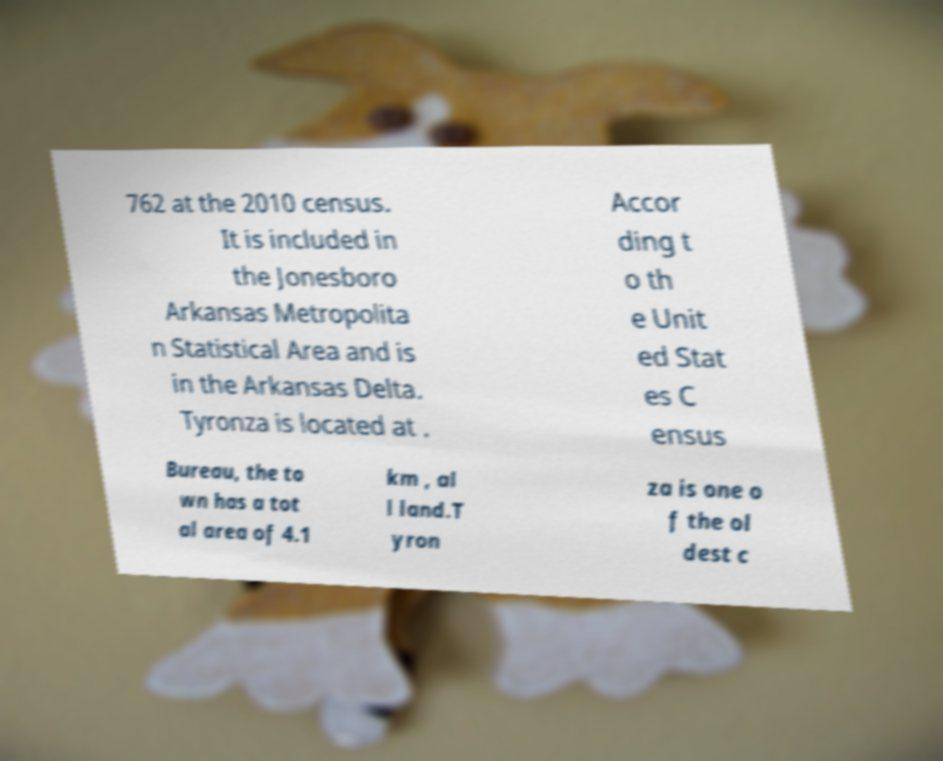Please read and relay the text visible in this image. What does it say? 762 at the 2010 census. It is included in the Jonesboro Arkansas Metropolita n Statistical Area and is in the Arkansas Delta. Tyronza is located at . Accor ding t o th e Unit ed Stat es C ensus Bureau, the to wn has a tot al area of 4.1 km , al l land.T yron za is one o f the ol dest c 